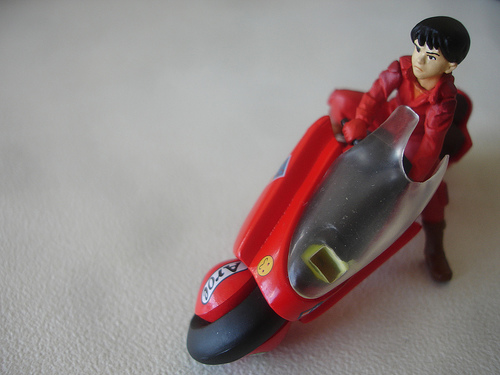<image>
Can you confirm if the man is behind the motorcycle? No. The man is not behind the motorcycle. From this viewpoint, the man appears to be positioned elsewhere in the scene. 